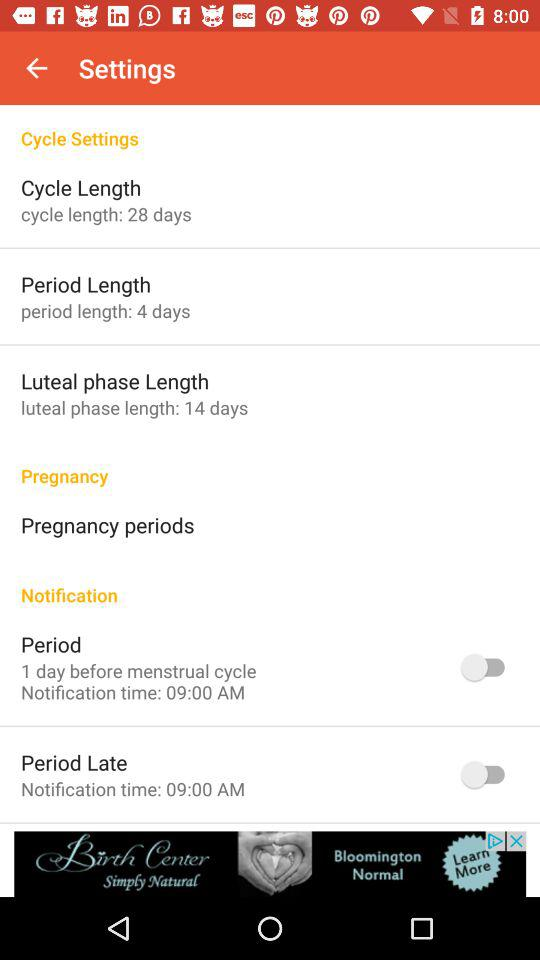What is the luteal phase length? The luteal phase length is 14 days. 